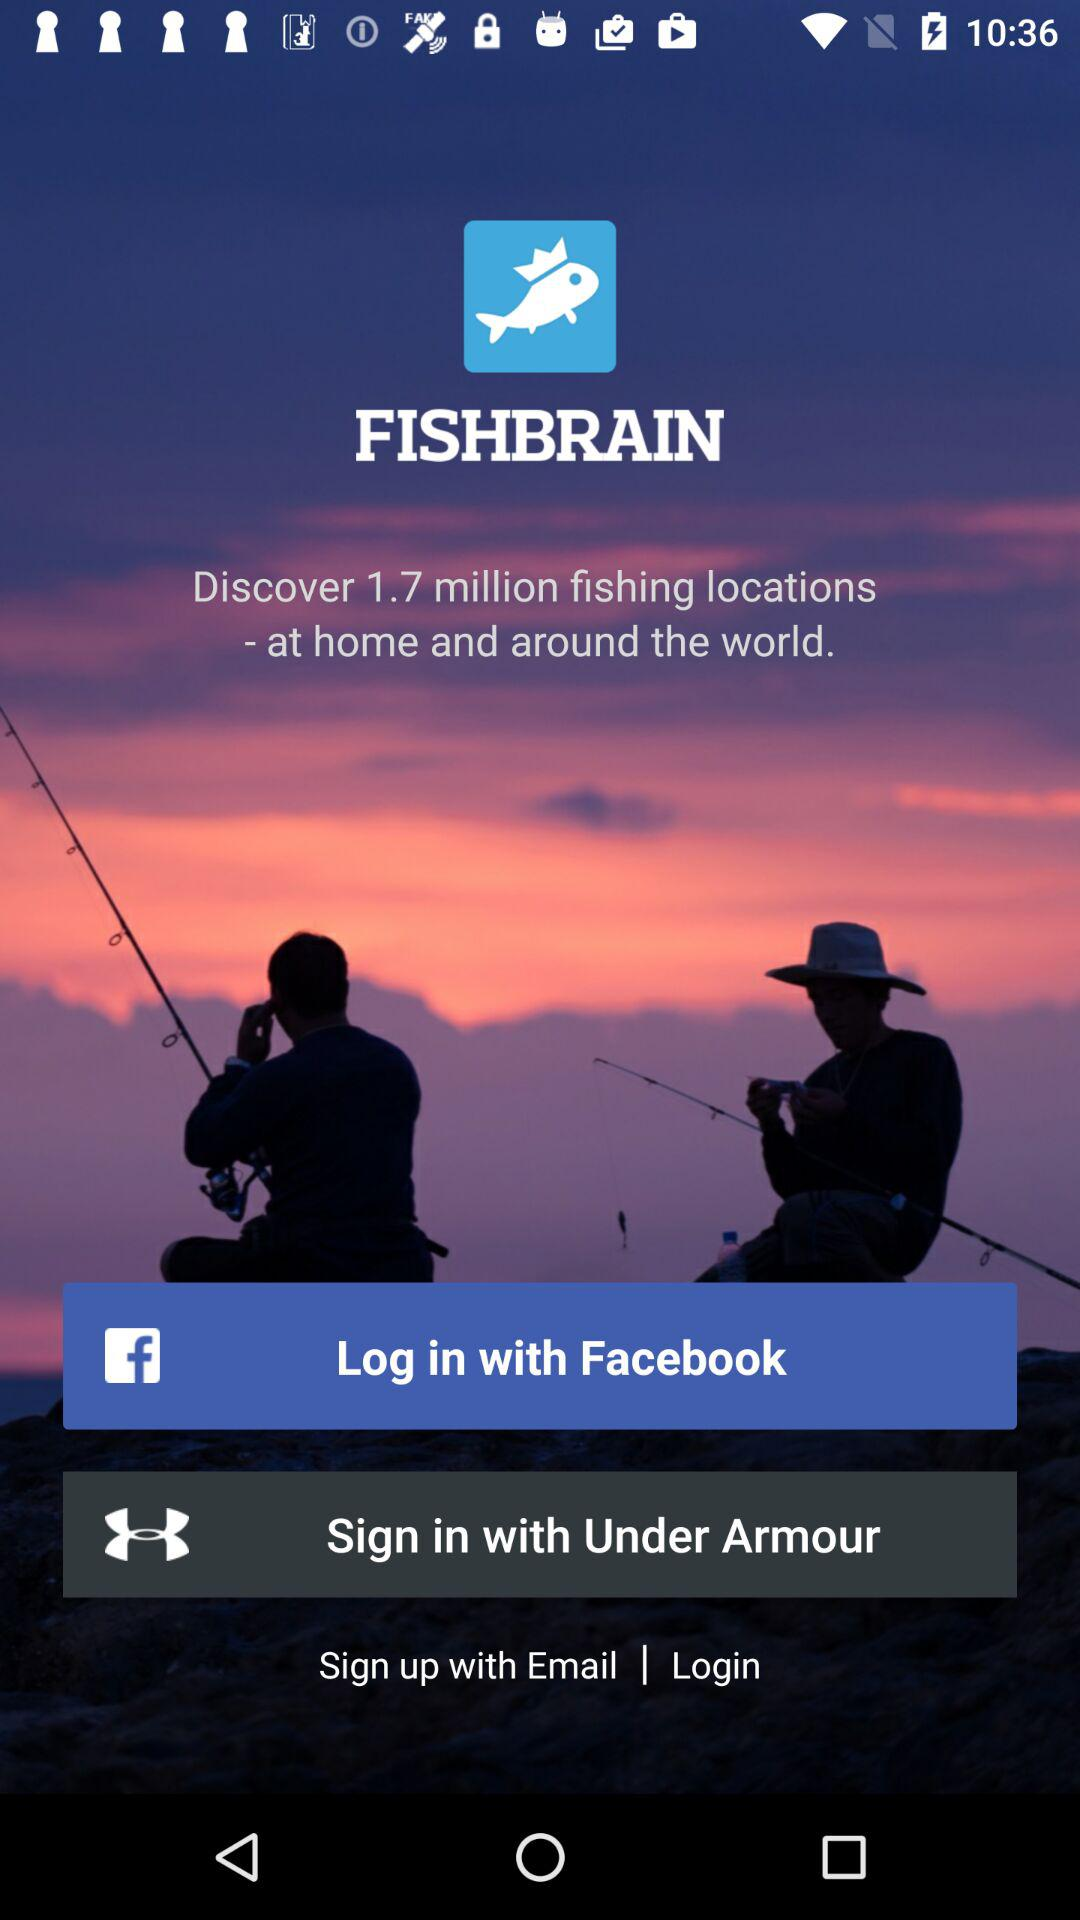How many fishing locations can I discover? You can discover 1.7 million fishing locations. 